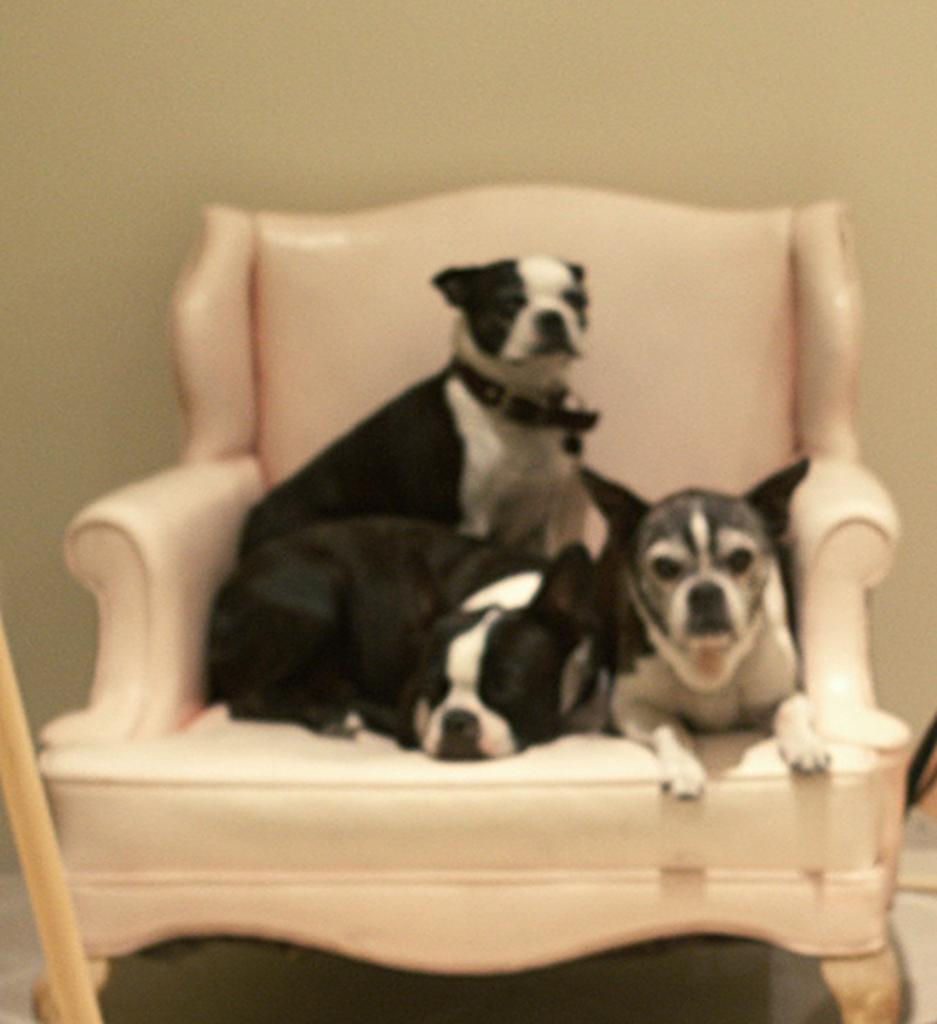What type of furniture is in the image? There is a chair in the image. What is on the chair? There are dogs on the chair. What can be seen in the background of the image? There is a wall in the background of the image. What is on the left side of the image? There is a stick on the left side of the image. What type of pot is being used for destruction in the image? There is no pot or destruction present in the image. 